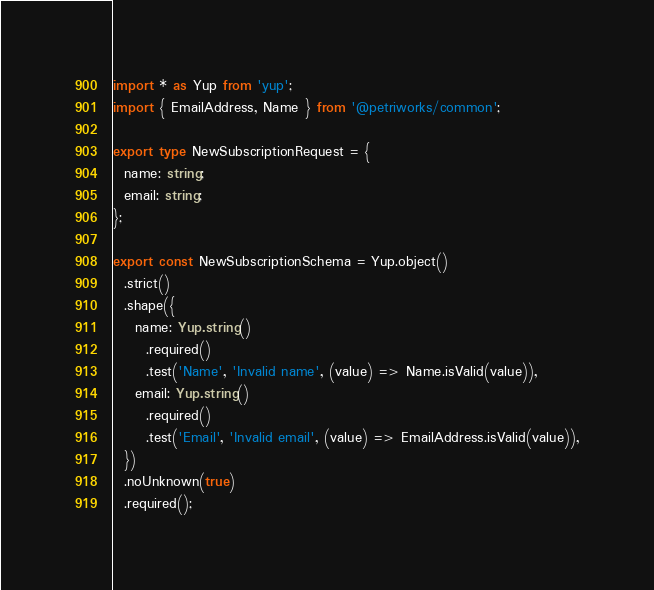Convert code to text. <code><loc_0><loc_0><loc_500><loc_500><_TypeScript_>import * as Yup from 'yup';
import { EmailAddress, Name } from '@petriworks/common';

export type NewSubscriptionRequest = {
  name: string;
  email: string;
};

export const NewSubscriptionSchema = Yup.object()
  .strict()
  .shape({
    name: Yup.string()
      .required()
      .test('Name', 'Invalid name', (value) => Name.isValid(value)),
    email: Yup.string()
      .required()
      .test('Email', 'Invalid email', (value) => EmailAddress.isValid(value)),
  })
  .noUnknown(true)
  .required();
</code> 